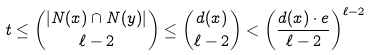Convert formula to latex. <formula><loc_0><loc_0><loc_500><loc_500>t \leq \binom { | N ( x ) \cap N ( y ) | } { \ell - 2 } \leq \binom { d ( x ) } { \ell - 2 } < \left ( \frac { d ( x ) \cdot e } { \ell - 2 } \right ) ^ { \ell - 2 }</formula> 